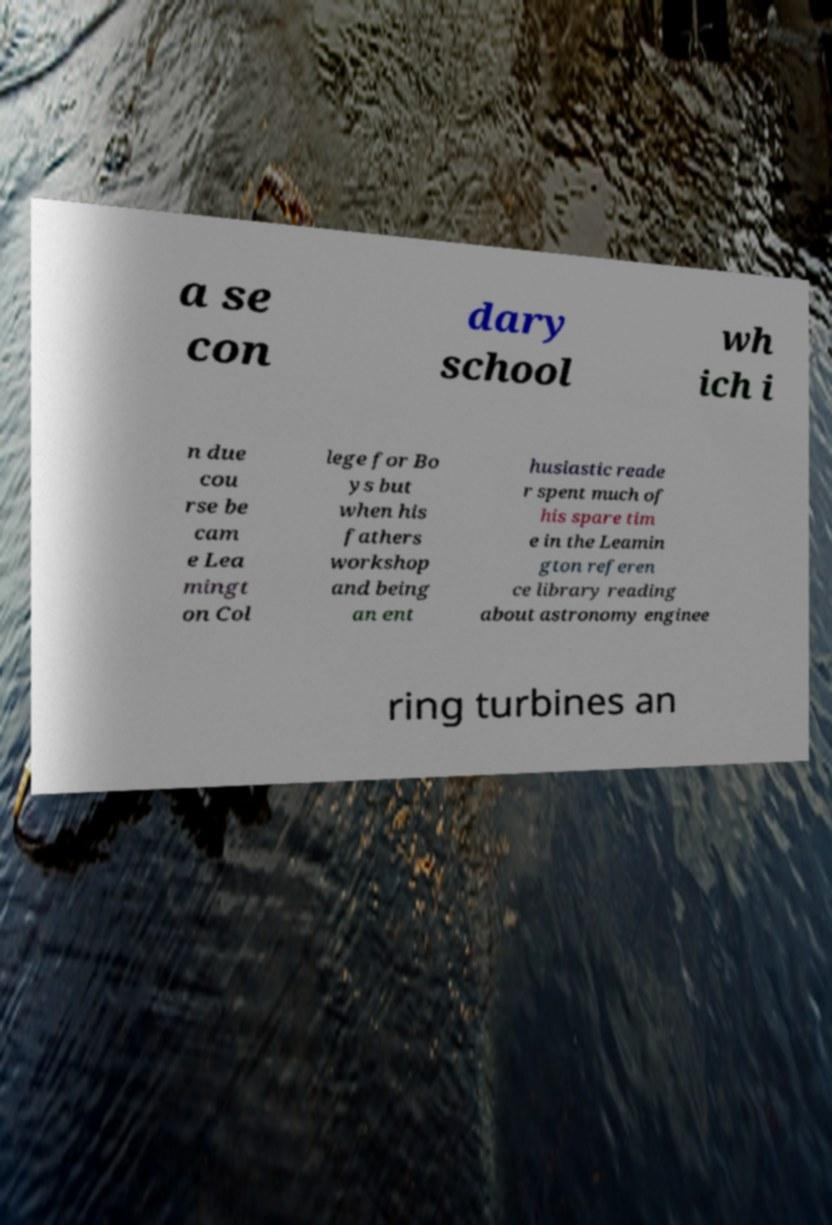Could you extract and type out the text from this image? a se con dary school wh ich i n due cou rse be cam e Lea mingt on Col lege for Bo ys but when his fathers workshop and being an ent husiastic reade r spent much of his spare tim e in the Leamin gton referen ce library reading about astronomy enginee ring turbines an 